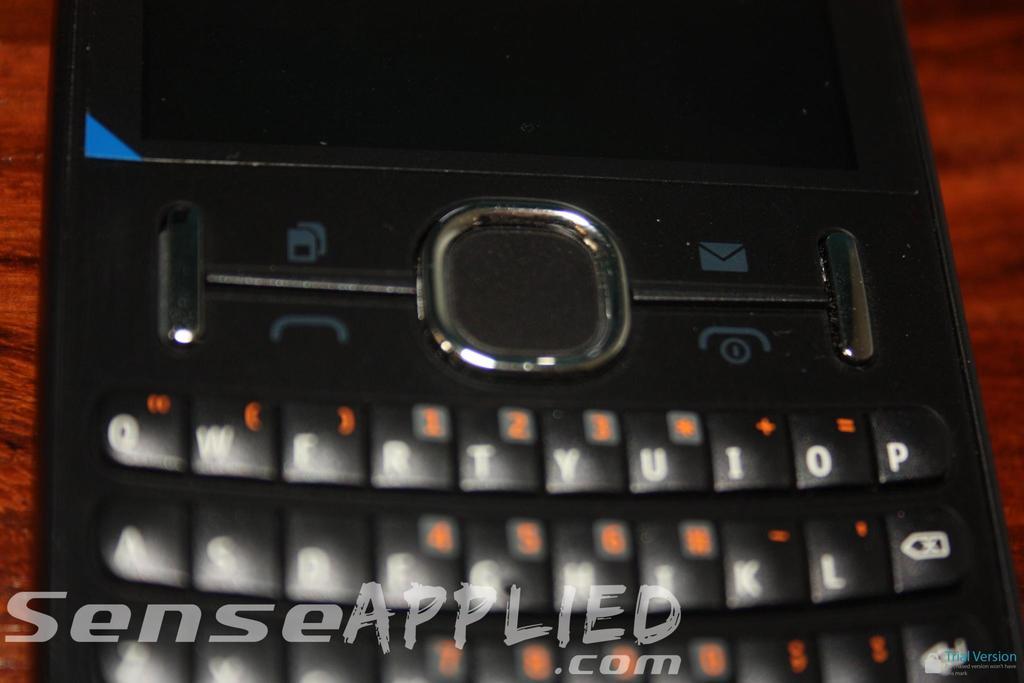What letter is on the top right?
Your answer should be very brief. P. What website is listed on the image?
Offer a very short reply. Senseapplied.com. 